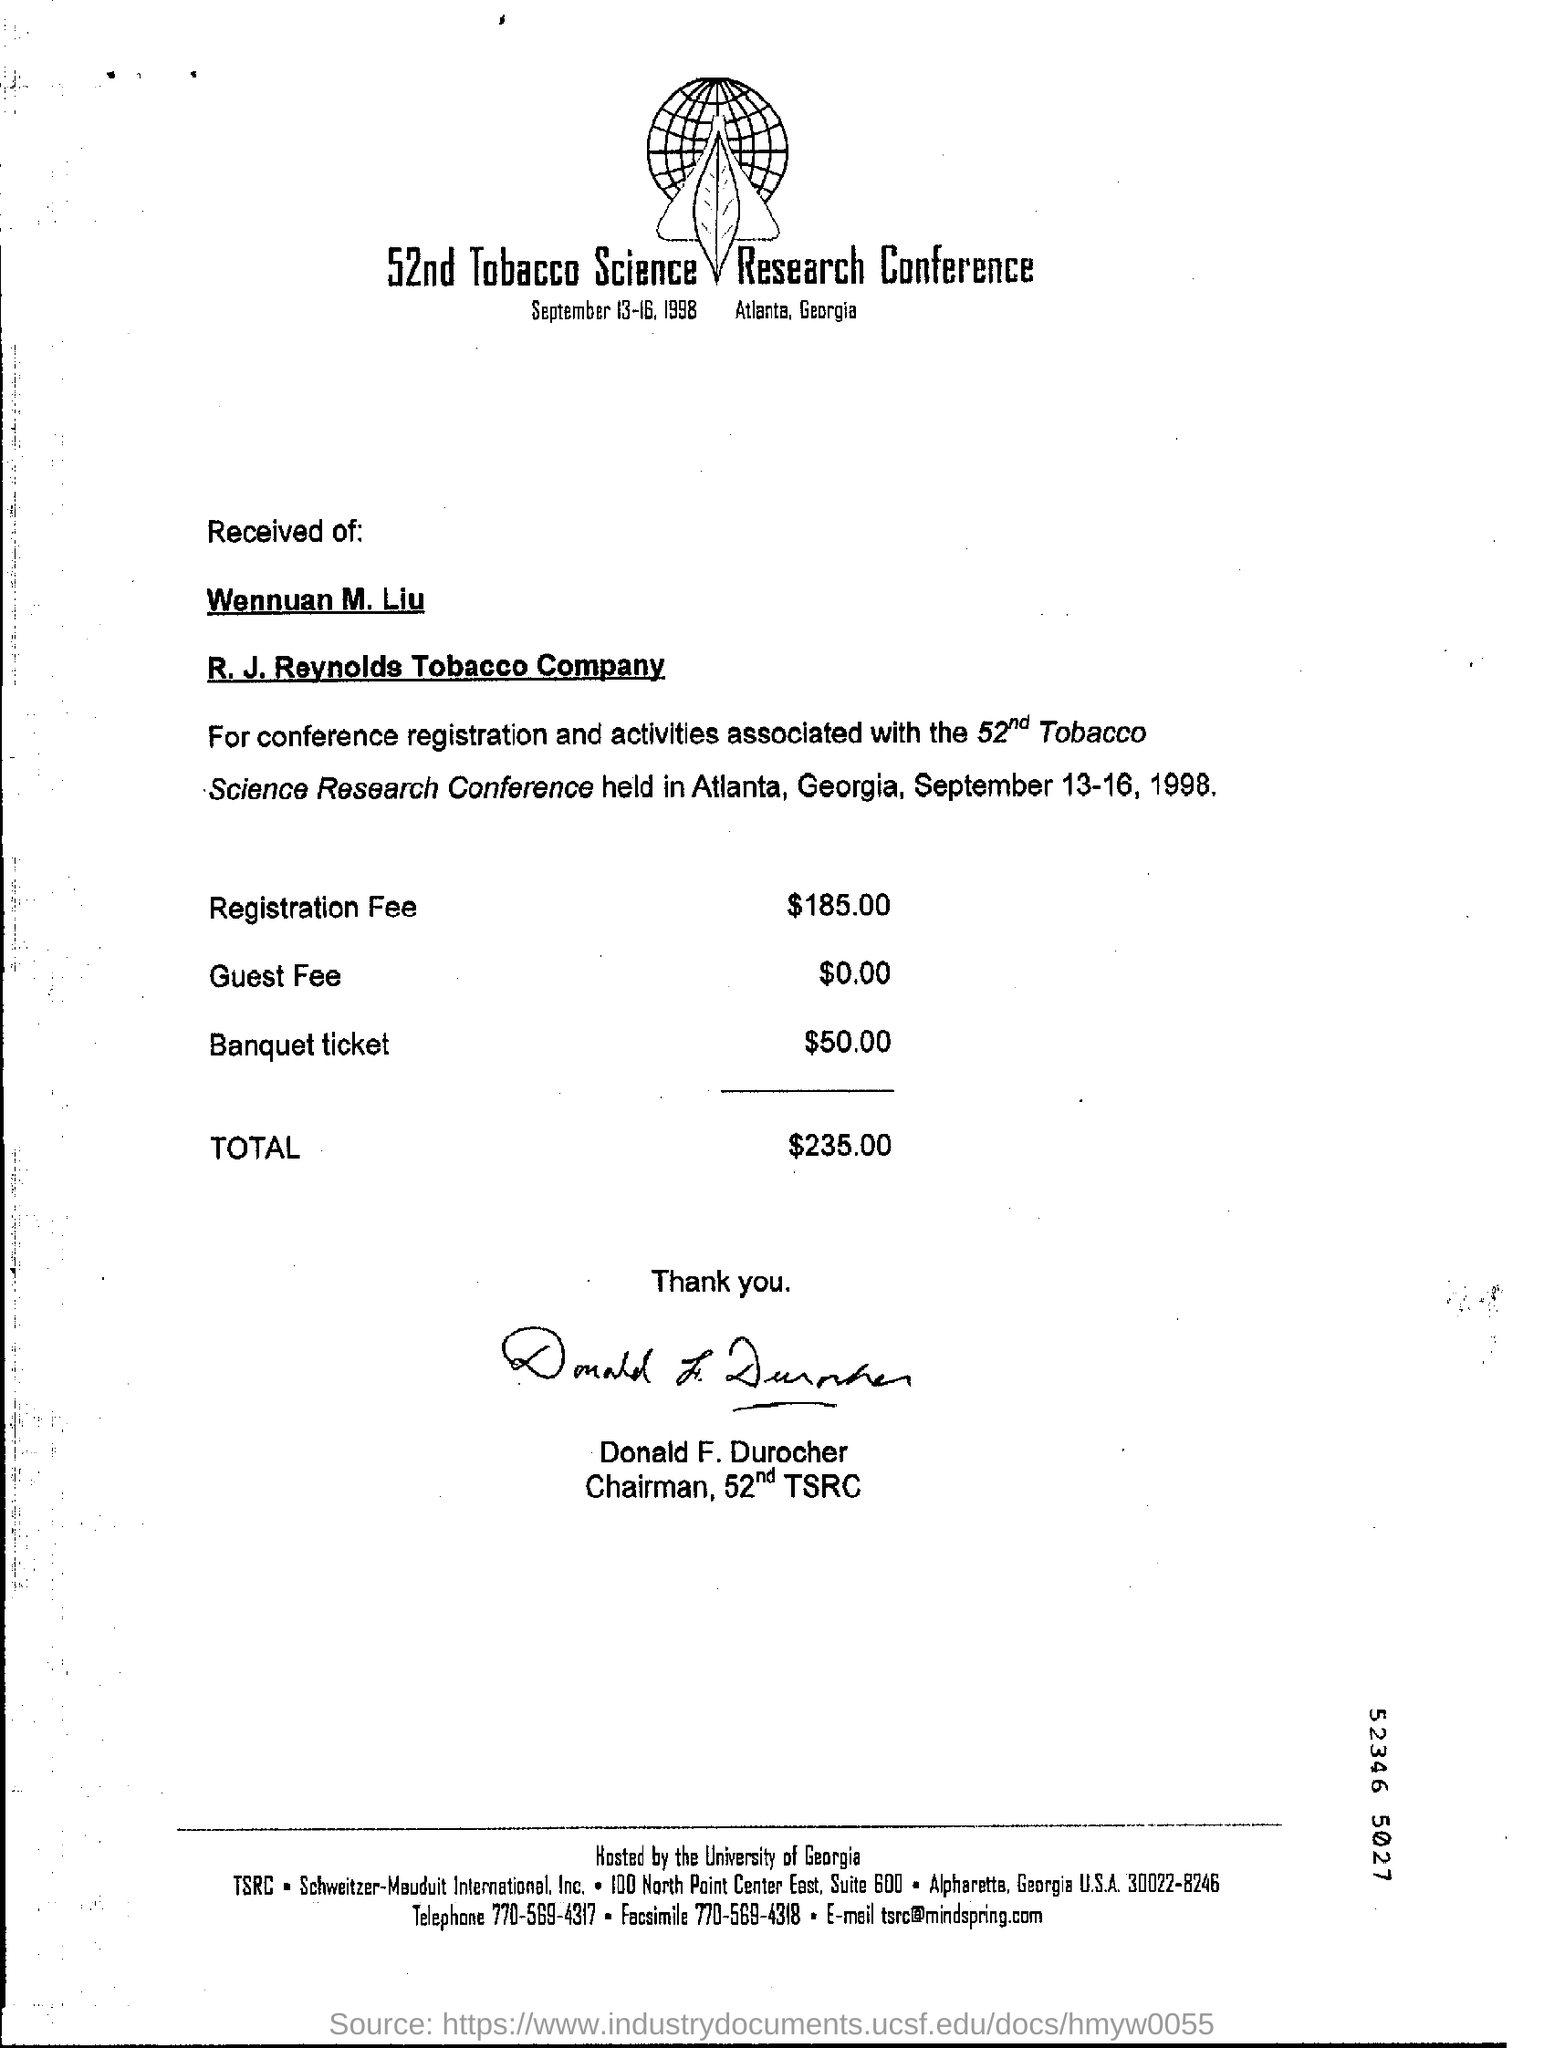What is the registration fee mentioned in conference?
Ensure brevity in your answer.  $185.00. What are the dates of the conference?
Offer a very short reply. September 13-16, 1998. Who is the chairman for this conference?
Keep it short and to the point. Donald F.Durocher. 